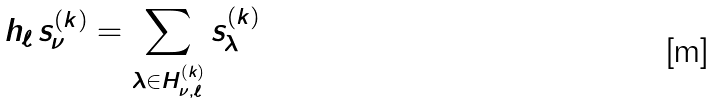<formula> <loc_0><loc_0><loc_500><loc_500>h _ { \ell } \, s _ { \nu } ^ { ( k ) } = \sum _ { \lambda \in H _ { \nu , \ell } ^ { ( k ) } } s _ { \lambda } ^ { ( k ) }</formula> 